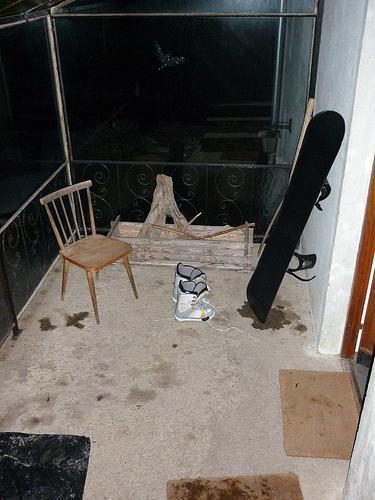How many snowboarding shoes are there?
Give a very brief answer. 2. How many mats are on the floor?
Give a very brief answer. 3. 